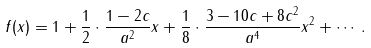Convert formula to latex. <formula><loc_0><loc_0><loc_500><loc_500>f ( x ) = 1 + \frac { 1 } { 2 } \cdot \frac { 1 - 2 c } { a ^ { 2 } } x + \frac { 1 } { 8 } \cdot \frac { 3 - 1 0 c + 8 c ^ { 2 } } { a ^ { 4 } } x ^ { 2 } + \cdots .</formula> 